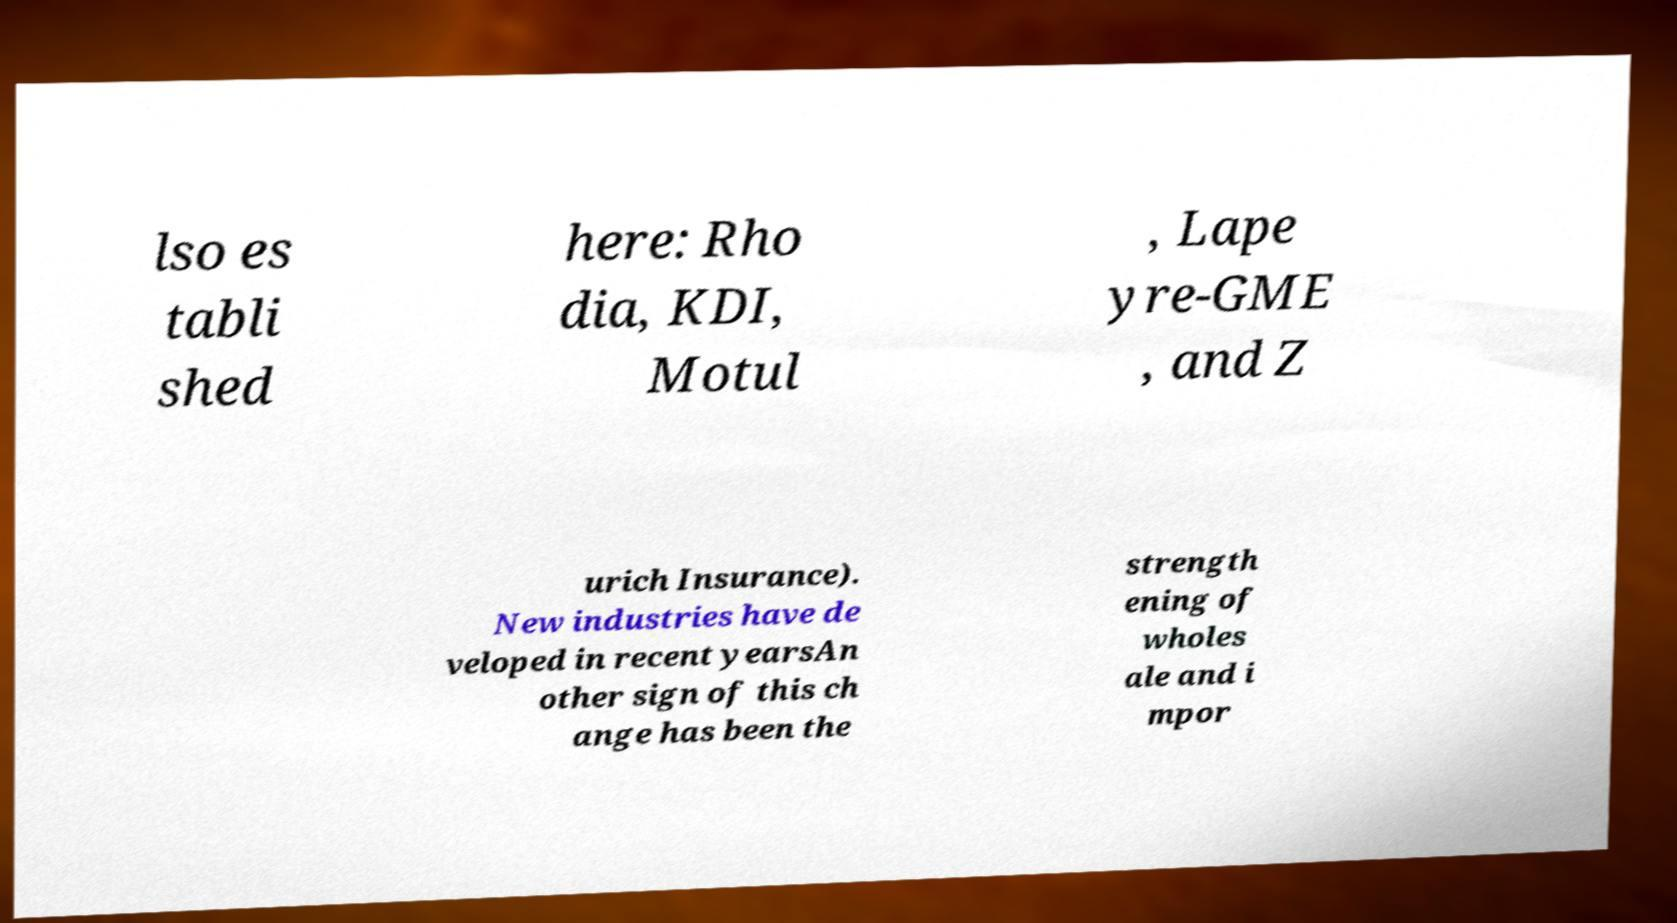For documentation purposes, I need the text within this image transcribed. Could you provide that? lso es tabli shed here: Rho dia, KDI, Motul , Lape yre-GME , and Z urich Insurance). New industries have de veloped in recent yearsAn other sign of this ch ange has been the strength ening of wholes ale and i mpor 